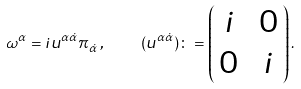<formula> <loc_0><loc_0><loc_500><loc_500>\omega ^ { \alpha } = i u ^ { \alpha \dot { \alpha } } \pi _ { \dot { \alpha } } \, , \quad \, ( u ^ { \alpha \dot { \alpha } } ) \colon = \begin{pmatrix} \, i & \, 0 \, \\ \, 0 & \, i \, \end{pmatrix} .</formula> 